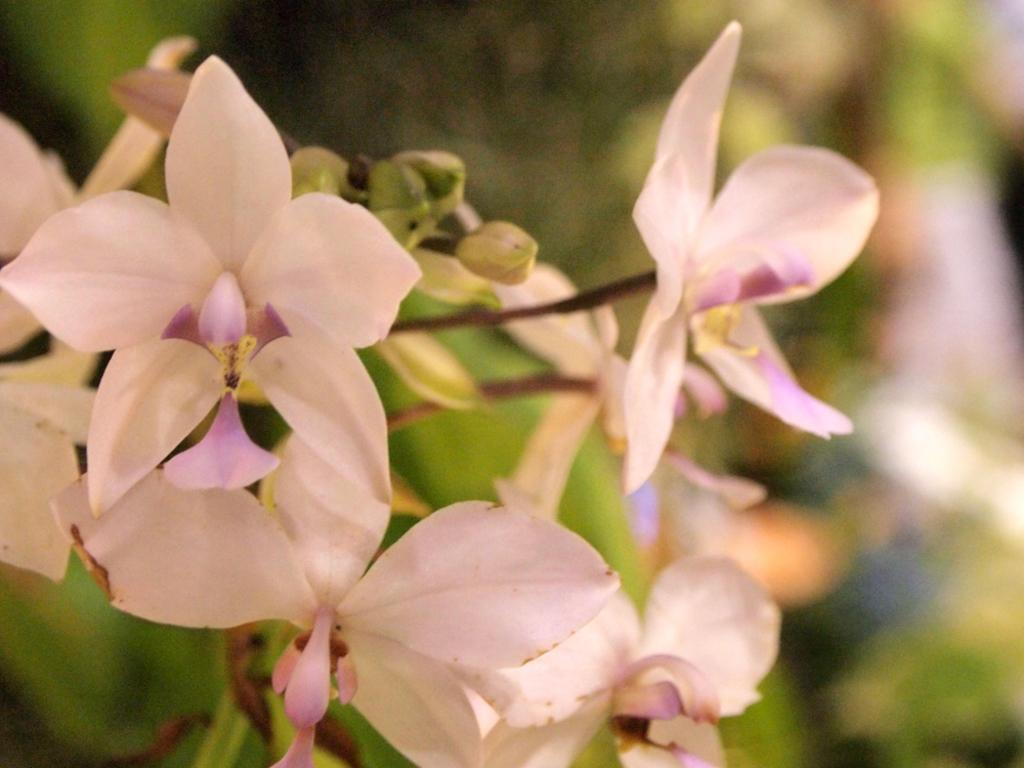What colors are the flowers in the image? The flowers in the image are white and purple. Can you describe the background of the image? The background is green and blurred. What type of pie is being served in the image? There is no pie present in the image; it features white and purple flowers with a green and blurred background. 